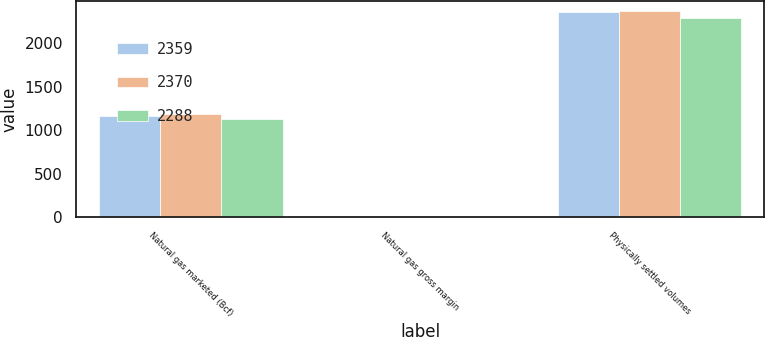Convert chart. <chart><loc_0><loc_0><loc_500><loc_500><stacked_bar_chart><ecel><fcel>Natural gas marketed (Bcf)<fcel>Natural gas gross margin<fcel>Physically settled volumes<nl><fcel>2359<fcel>1160<fcel>0.07<fcel>2359<nl><fcel>2370<fcel>1191<fcel>0.19<fcel>2370<nl><fcel>2288<fcel>1132<fcel>0.22<fcel>2288<nl></chart> 